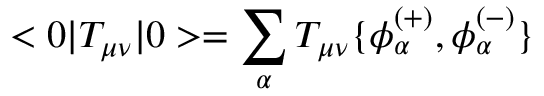Convert formula to latex. <formula><loc_0><loc_0><loc_500><loc_500>< 0 | T _ { \mu \nu } | 0 > = \sum _ { \alpha } T _ { \mu \nu } \{ \phi _ { \alpha } ^ { ( + ) } , \phi _ { \alpha } ^ { ( - ) } \}</formula> 